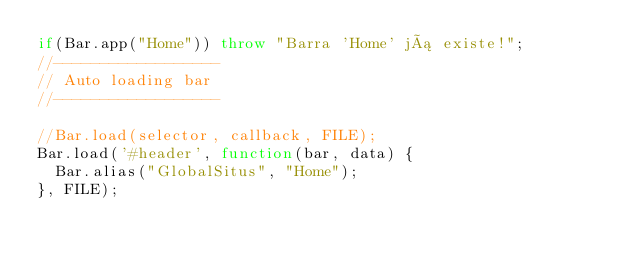Convert code to text. <code><loc_0><loc_0><loc_500><loc_500><_JavaScript_>if(Bar.app("Home")) throw "Barra 'Home' já existe!";
//------------------
// Auto loading bar
//------------------

//Bar.load(selector, callback, FILE);
Bar.load('#header', function(bar, data) {
	Bar.alias("GlobalSitus", "Home");
}, FILE);
</code> 